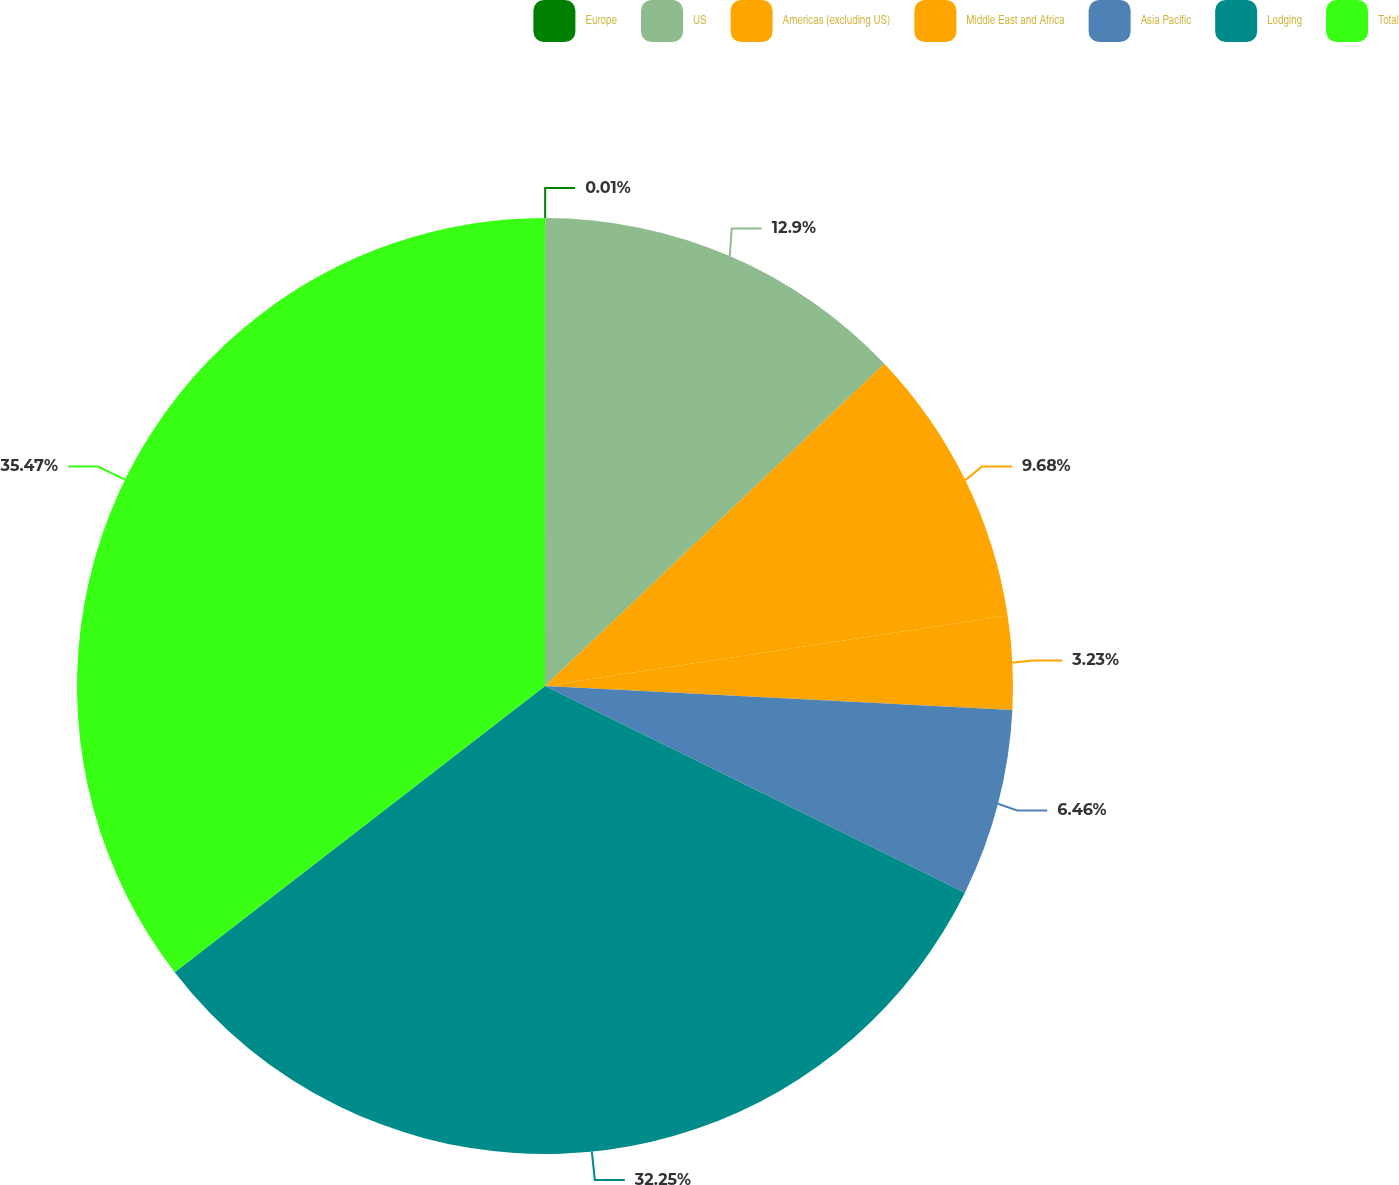Convert chart. <chart><loc_0><loc_0><loc_500><loc_500><pie_chart><fcel>Europe<fcel>US<fcel>Americas (excluding US)<fcel>Middle East and Africa<fcel>Asia Pacific<fcel>Lodging<fcel>Total<nl><fcel>0.01%<fcel>12.9%<fcel>9.68%<fcel>3.23%<fcel>6.46%<fcel>32.25%<fcel>35.47%<nl></chart> 